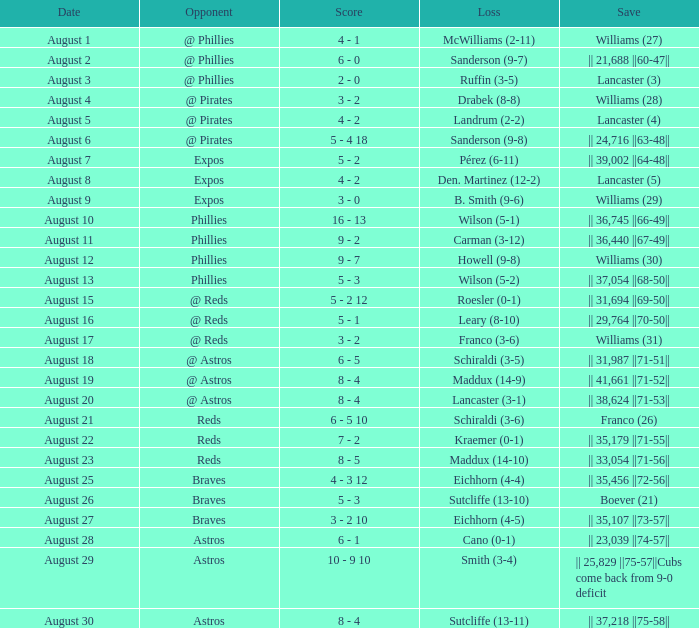Name the date with loss of carman (3-12) August 11. 